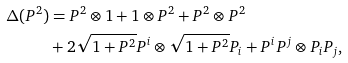<formula> <loc_0><loc_0><loc_500><loc_500>\Delta ( P ^ { 2 } ) & = P ^ { 2 } \otimes 1 + 1 \otimes P ^ { 2 } + P ^ { 2 } \otimes P ^ { 2 } \\ & + 2 \sqrt { 1 + P ^ { 2 } } P ^ { i } \otimes \sqrt { 1 + P ^ { 2 } } P _ { i } + P ^ { i } P ^ { j } \otimes P _ { i } P _ { j } ,</formula> 